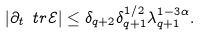<formula> <loc_0><loc_0><loc_500><loc_500>| \partial _ { t } \ t r \mathcal { E } | \leq \delta _ { q + 2 } \delta _ { q + 1 } ^ { 1 / 2 } \lambda _ { q + 1 } ^ { 1 - 3 \alpha } .</formula> 